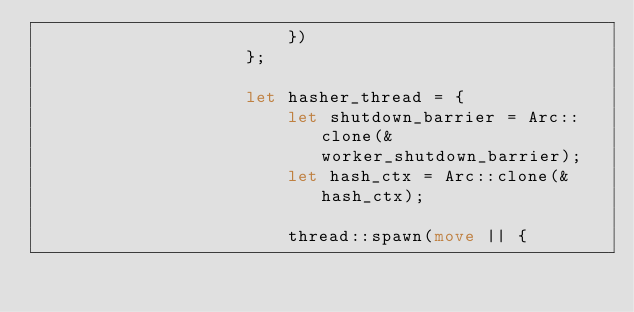<code> <loc_0><loc_0><loc_500><loc_500><_Rust_>                        })
                    };

                    let hasher_thread = {
                        let shutdown_barrier = Arc::clone(&worker_shutdown_barrier);
                        let hash_ctx = Arc::clone(&hash_ctx);

                        thread::spawn(move || {</code> 